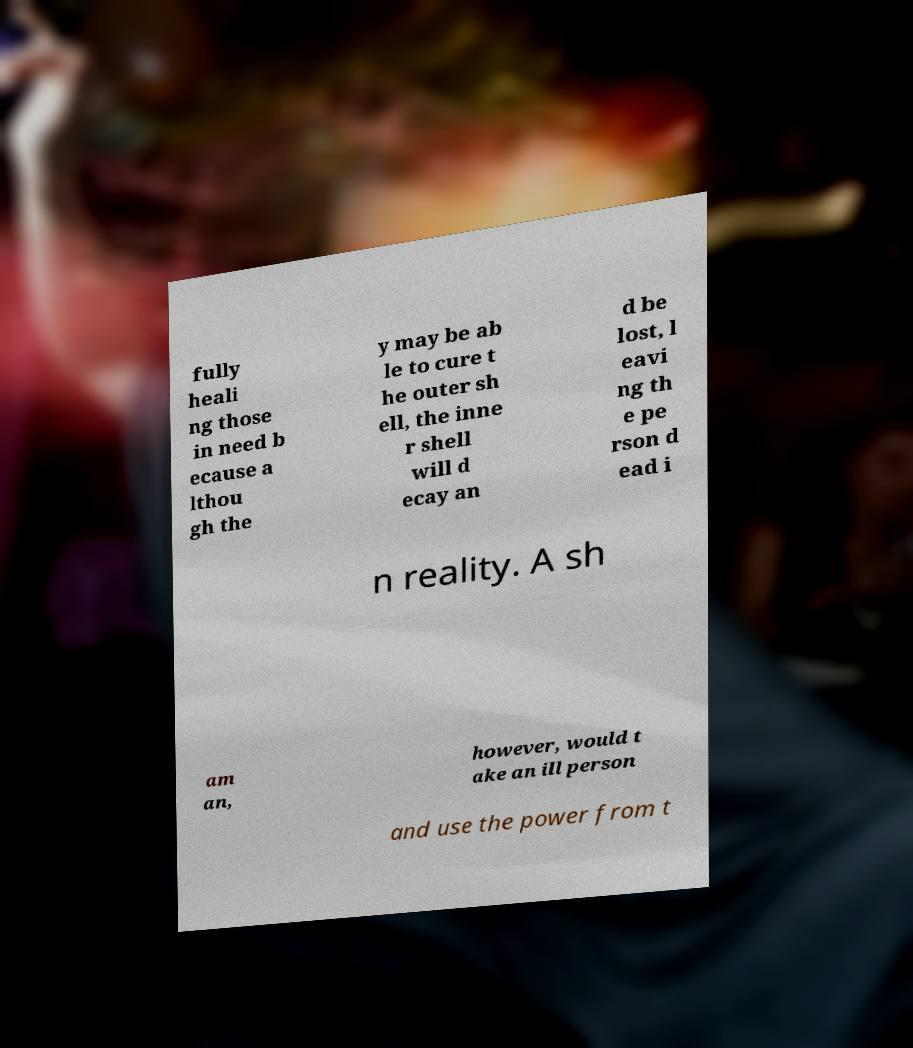Could you assist in decoding the text presented in this image and type it out clearly? fully heali ng those in need b ecause a lthou gh the y may be ab le to cure t he outer sh ell, the inne r shell will d ecay an d be lost, l eavi ng th e pe rson d ead i n reality. A sh am an, however, would t ake an ill person and use the power from t 